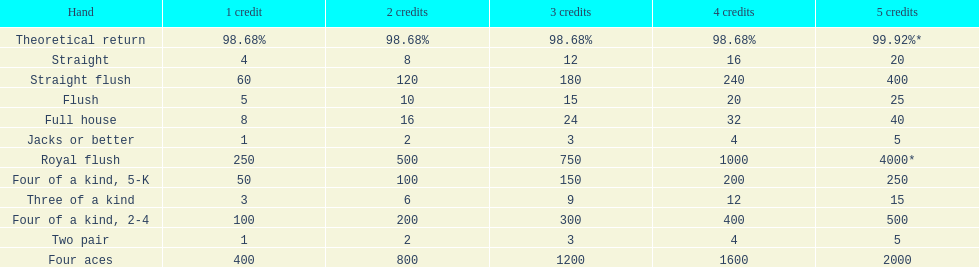Is four 5s worth more or less than four 2s? Less. 